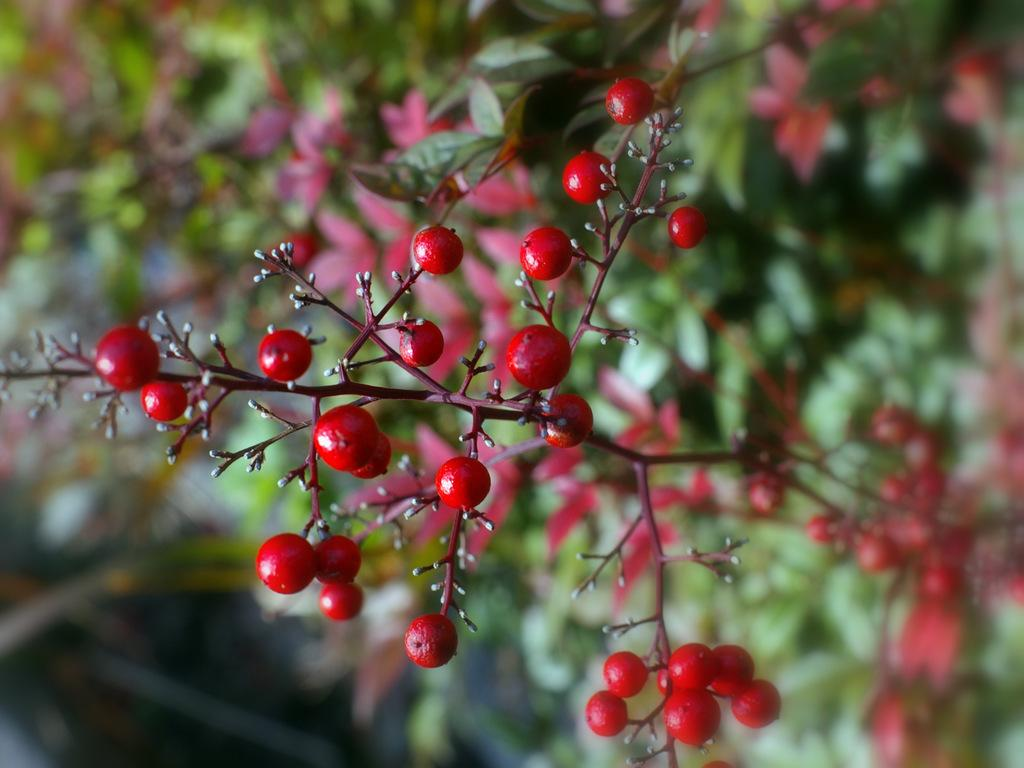What is the main subject of the image? The main subject of the image is many plants. What can be seen on the plants in the image? There are fruits on the plants in the image. What type of fog can be seen surrounding the plants in the image? There is no fog present in the image; it features plants with fruits. 